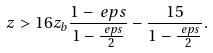Convert formula to latex. <formula><loc_0><loc_0><loc_500><loc_500>z & > 1 6 z _ { b } \frac { 1 - \ e p s } { 1 - \frac { \ e p s } { 2 } } - \frac { 1 5 } { 1 - \frac { \ e p s } { 2 } } .</formula> 